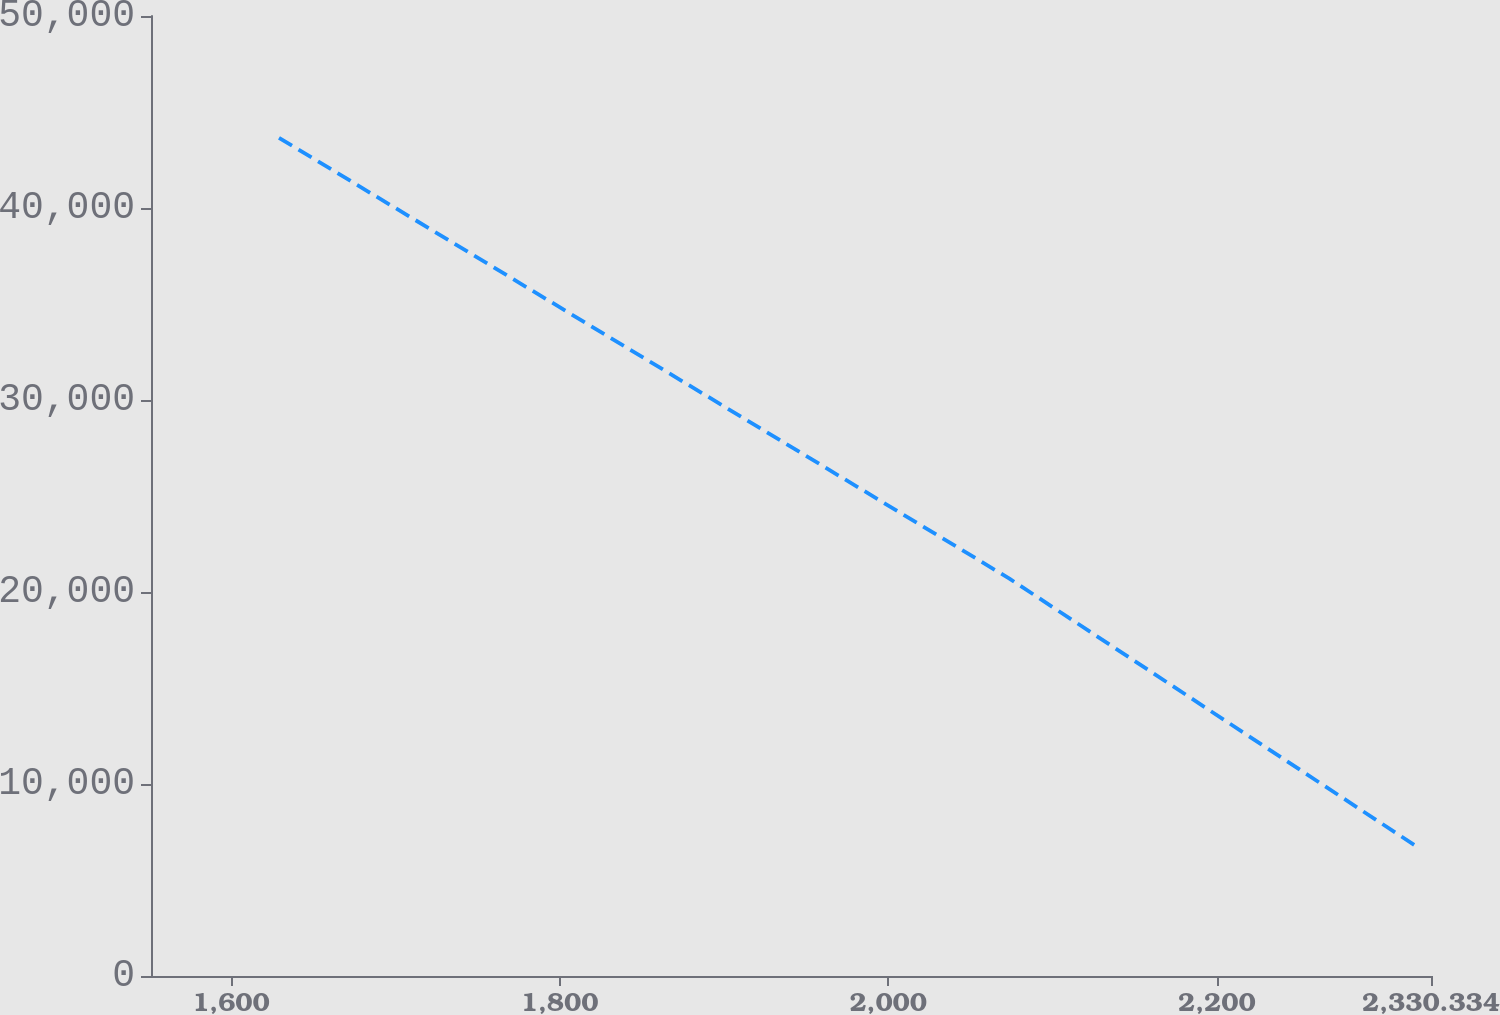Convert chart. <chart><loc_0><loc_0><loc_500><loc_500><line_chart><ecel><fcel>Amortization<nl><fcel>1629.27<fcel>43657.4<nl><fcel>2073.78<fcel>20695.5<nl><fcel>2322.24<fcel>6706.75<nl><fcel>2408.23<fcel>10401.8<nl></chart> 